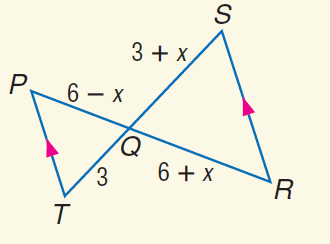Answer the mathemtical geometry problem and directly provide the correct option letter.
Question: Find x.
Choices: A: - 3 B: 0 C: 3 D: 6 B 